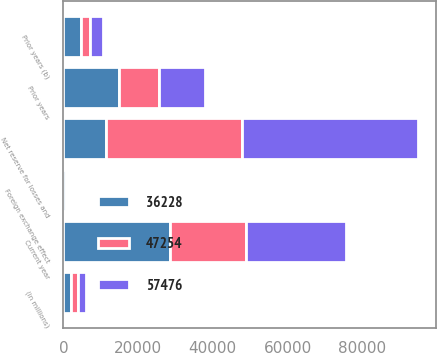Convert chart to OTSL. <chart><loc_0><loc_0><loc_500><loc_500><stacked_bar_chart><ecel><fcel>(in millions)<fcel>Net reserve for losses and<fcel>Foreign exchange effect<fcel>Current year<fcel>Prior years (b)<fcel>Prior years<nl><fcel>36228<fcel>2005<fcel>11469<fcel>628<fcel>28426<fcel>4665<fcel>14910<nl><fcel>57476<fcel>2004<fcel>47254<fcel>524<fcel>26793<fcel>3564<fcel>12163<nl><fcel>47254<fcel>2003<fcel>36228<fcel>580<fcel>20509<fcel>2363<fcel>10775<nl></chart> 